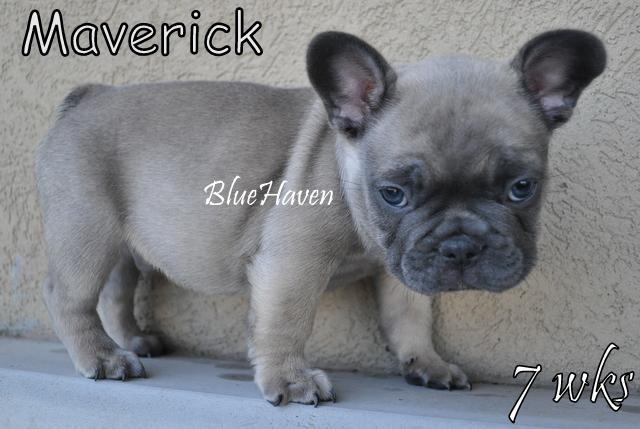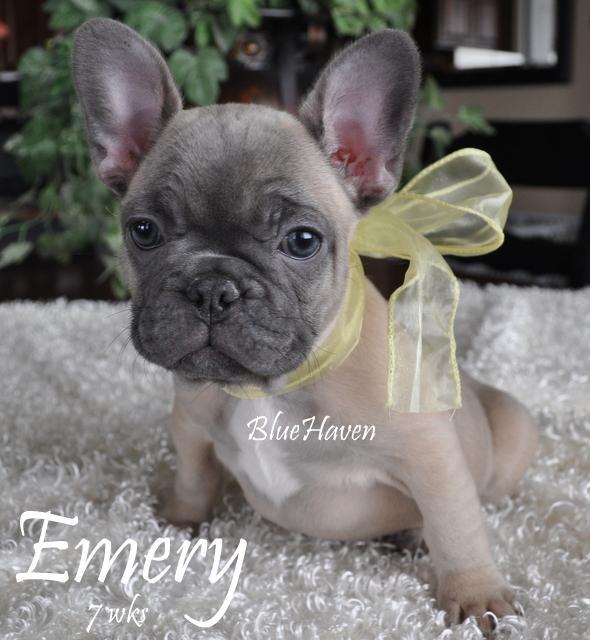The first image is the image on the left, the second image is the image on the right. For the images shown, is this caption "The right image shows a big-eared dog with light blue eyes, and the left image shows a dog standing on all fours with its body turned forward." true? Answer yes or no. No. The first image is the image on the left, the second image is the image on the right. Considering the images on both sides, is "There are exactly two french bulldogs that are located outdoors." valid? Answer yes or no. No. 